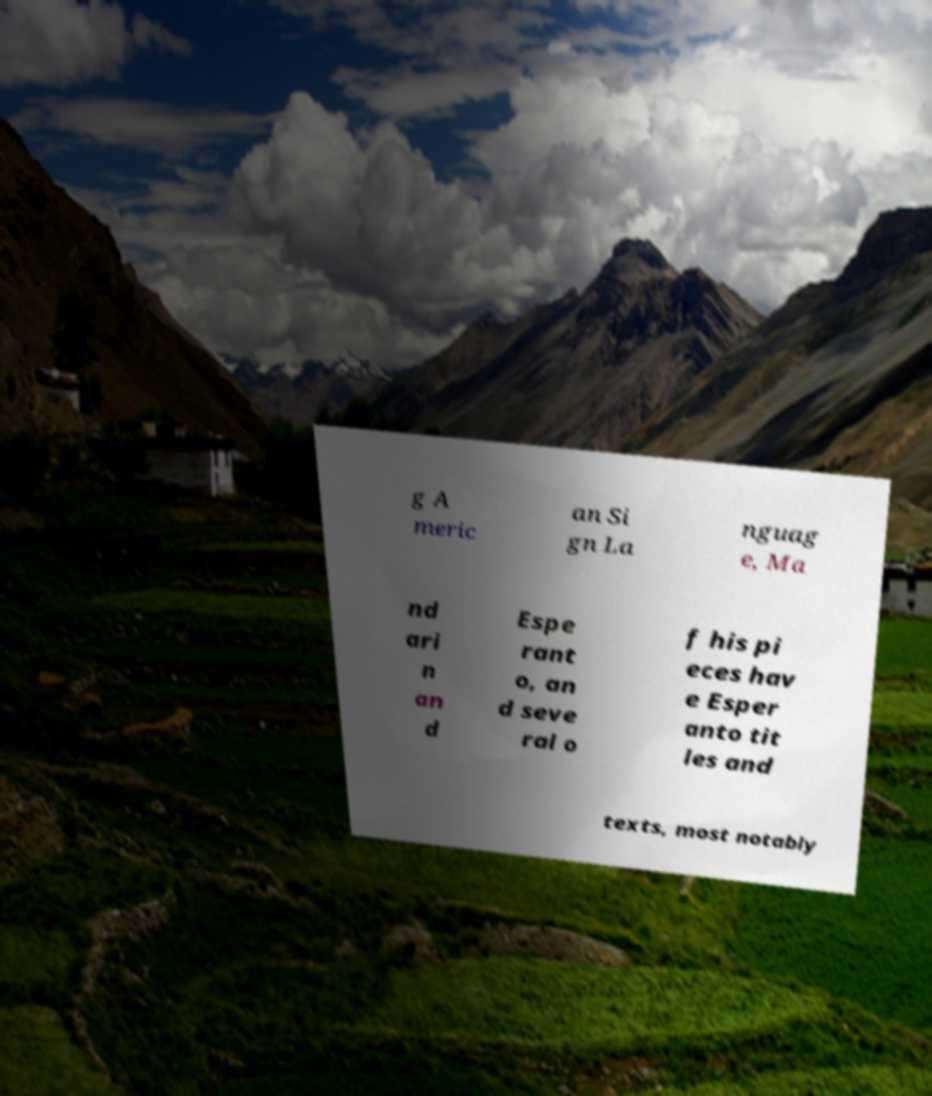Please identify and transcribe the text found in this image. g A meric an Si gn La nguag e, Ma nd ari n an d Espe rant o, an d seve ral o f his pi eces hav e Esper anto tit les and texts, most notably 